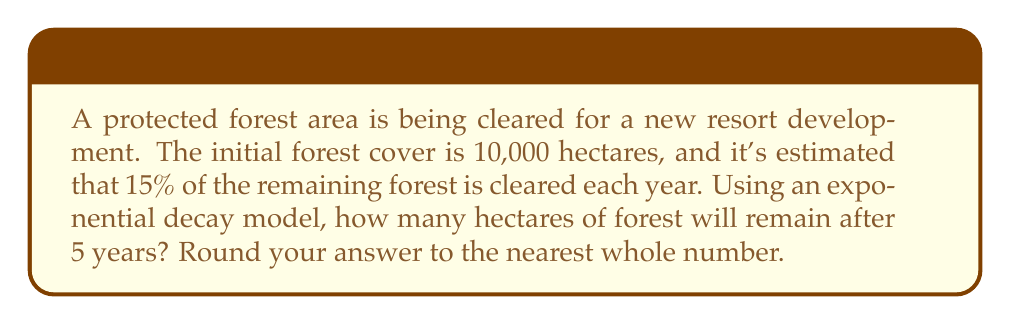Give your solution to this math problem. To solve this problem, we'll use the exponential decay formula:

$$A(t) = A_0 \cdot (1-r)^t$$

Where:
$A(t)$ is the amount remaining after time $t$
$A_0$ is the initial amount
$r$ is the decay rate (percentage expressed as a decimal)
$t$ is the time in years

Given:
$A_0 = 10,000$ hectares
$r = 15\% = 0.15$
$t = 5$ years

Step 1: Plug the values into the formula
$$A(5) = 10,000 \cdot (1-0.15)^5$$

Step 2: Simplify the expression inside the parentheses
$$A(5) = 10,000 \cdot (0.85)^5$$

Step 3: Calculate the exponent
$$A(5) = 10,000 \cdot 0.4437053$$

Step 4: Multiply
$$A(5) = 4,437.053$$

Step 5: Round to the nearest whole number
$$A(5) \approx 4,437 \text{ hectares}$$
Answer: 4,437 hectares 